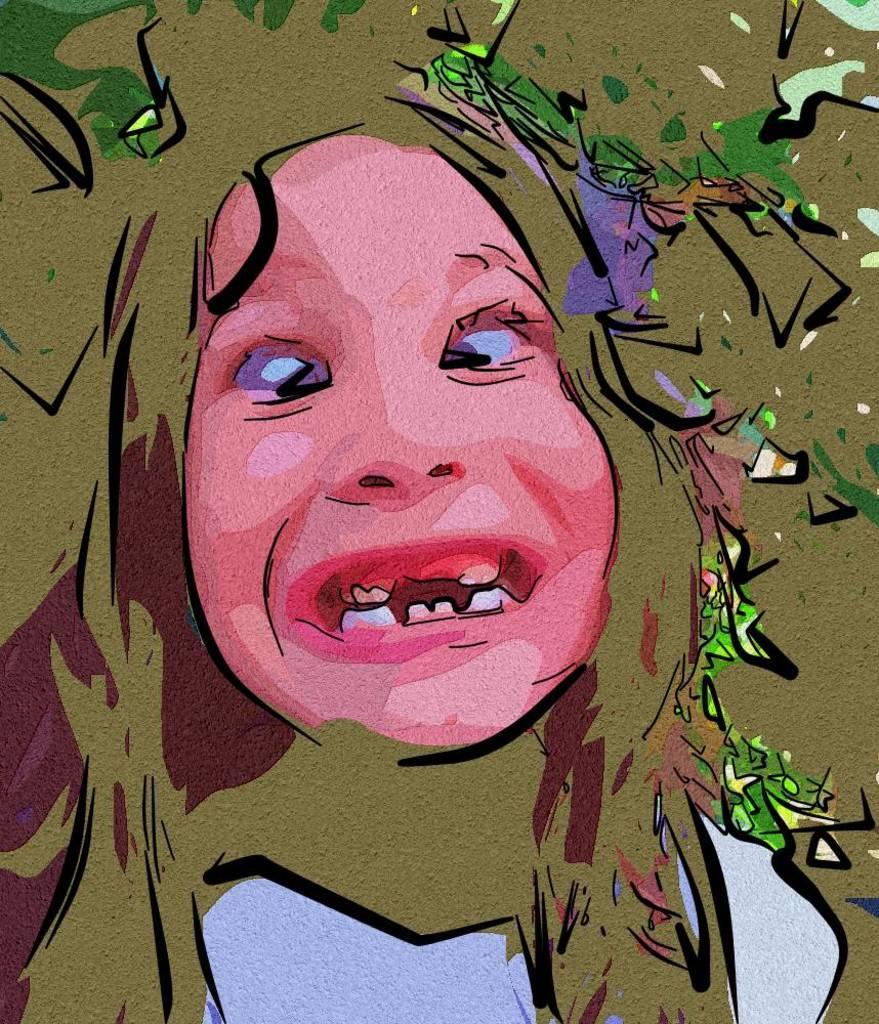How would you summarize this image in a sentence or two? Here we can see a graphical image, in this picture we can see a person's face in the middle. 